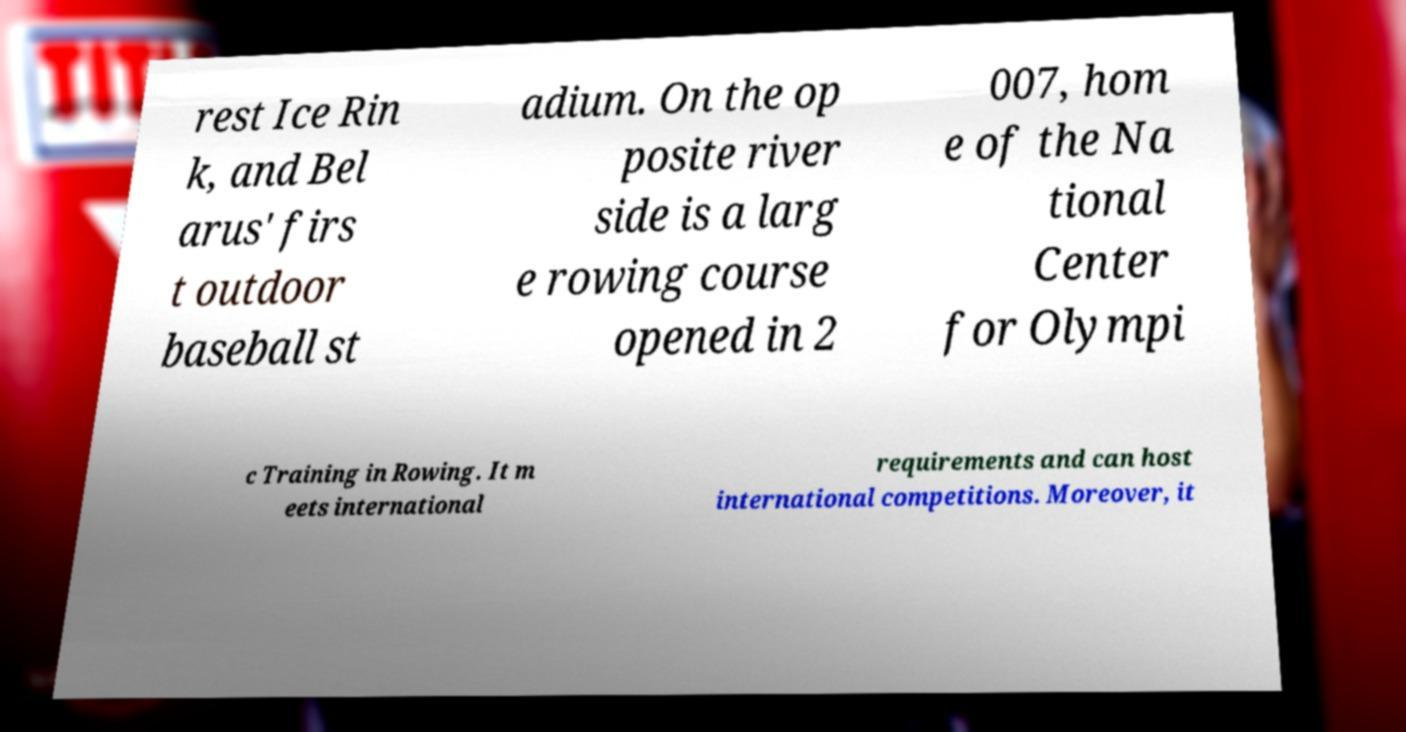What messages or text are displayed in this image? I need them in a readable, typed format. rest Ice Rin k, and Bel arus' firs t outdoor baseball st adium. On the op posite river side is a larg e rowing course opened in 2 007, hom e of the Na tional Center for Olympi c Training in Rowing. It m eets international requirements and can host international competitions. Moreover, it 